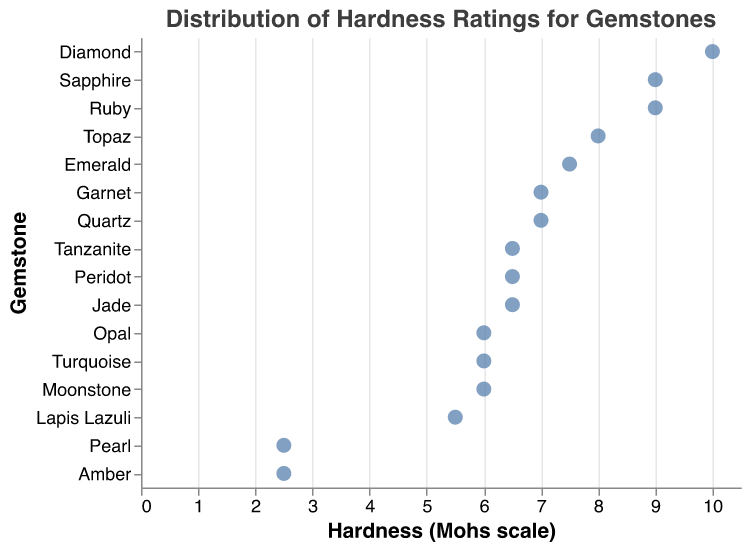What is the title of the figure? The title of the figure is displayed at the top. It reads "Distribution of Hardness Ratings for Gemstones".
Answer: Distribution of Hardness Ratings for Gemstones Which gemstone has the highest hardness rating? The gemstone with the highest hardness rating would be the one positioned furthest right on the x-axis. The figure shows Diamond at 10 on the Mohs scale.
Answer: Diamond Which gemstones have a hardness rating of 6.5? To find gemstones with a hardness rating of 6.5, look for points aligned vertically with the 6.5 mark on the x-axis. The gemstones are Peridot, Jade, and Tanzanite.
Answer: Peridot, Jade, Tanzanite How many unique hardness ratings are depicted in the figure? Count the unique x-axis values at which points are shown. There are ratings at 10, 9, 8, 7.5, 7, 6.5, 6, 5.5, and 2.5. So, there are 9 unique hardness ratings.
Answer: 9 What is the hardness rating of Lapis Lazuli? Find Lapis Lazuli on the y-axis and trace horizontally to the corresponding x-axis value. The hardness rating is 5.5.
Answer: 5.5 How much harder is Topaz compared to Opal? Subtract the hardness rating of Opal from that of Topaz. Topaz has a rating of 8 and Opal has 6, so 8 - 6 = 2.
Answer: 2 Which gemstone with a hardness of 7.5 is listed in the figure? Look for points aligned with the 7.5 mark on the x-axis. The gemstone with a 7.5 hardness rating is Emerald.
Answer: Emerald Are there more gemstones with a hardness rating above 8 or below 6? Count the number of points above 8 (Diamond, Sapphire, and Ruby - 3 total) and below 6 (Pearl and Amber - 2 total). There are more gemstones with hardness above 8.
Answer: Above 8 Identify two gemstones with the same hardness rating of 9. Observe the points aligned with the 9 mark on the x-axis. The two gemstones are Sapphire and Ruby.
Answer: Sapphire, Ruby Which gemstone is the least hard? Identify the gemstone with the smallest value on the x-axis. Both Pearl and Amber have the lowest hardness rating of 2.5.
Answer: Pearl, Amber 